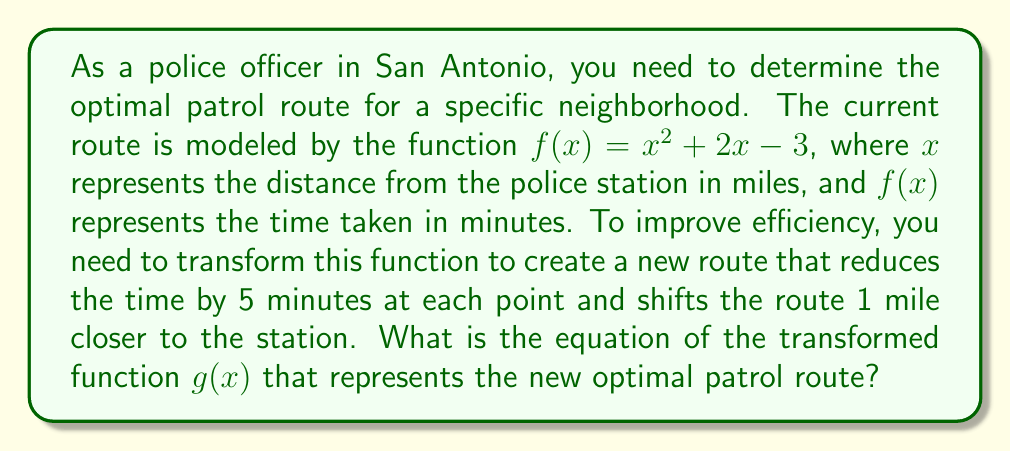Can you answer this question? To determine the transformed function $g(x)$, we need to apply two transformations to the original function $f(x) = x^2 + 2x - 3$:

1. Vertical shift: Reduce the time by 5 minutes at each point.
   This is represented by subtracting 5 from the function:
   $f(x) - 5$

2. Horizontal shift: Move the route 1 mile closer to the station.
   This is represented by replacing $x$ with $(x + 1)$:
   $f(x + 1)$

Let's apply these transformations step by step:

Step 1: Apply the horizontal shift
$$f(x + 1) = (x + 1)^2 + 2(x + 1) - 3$$

Step 2: Expand the squared term
$$f(x + 1) = x^2 + 2x + 1 + 2x + 2 - 3$$

Step 3: Simplify
$$f(x + 1) = x^2 + 4x$$

Step 4: Apply the vertical shift by subtracting 5
$$g(x) = f(x + 1) - 5 = x^2 + 4x - 5$$

Therefore, the transformed function $g(x)$ representing the new optimal patrol route is $x^2 + 4x - 5$.
Answer: $g(x) = x^2 + 4x - 5$ 